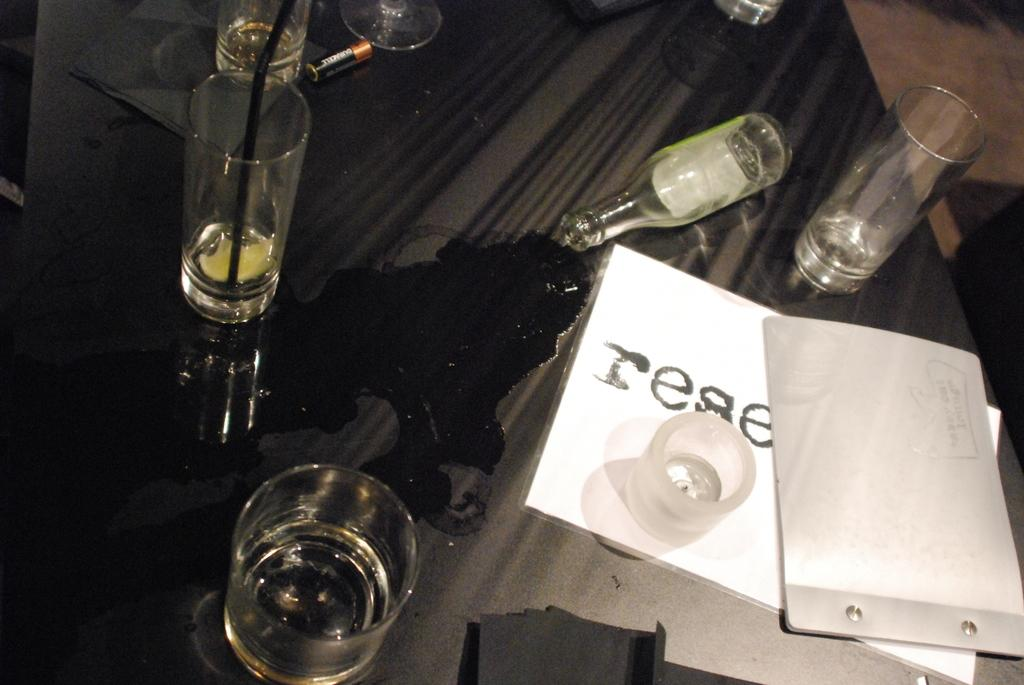What is one of the objects visible in the image? There is a bottle in the image. What else can be seen in the image besides the bottle? There are glasses and other objects visible in the image. Where are these objects located? These objects are on a platform. What can be seen in the background of the image? The floor is visible in the background of the image. Is anyone driving a vehicle in the image? No, there is no vehicle or driving activity depicted in the image. 